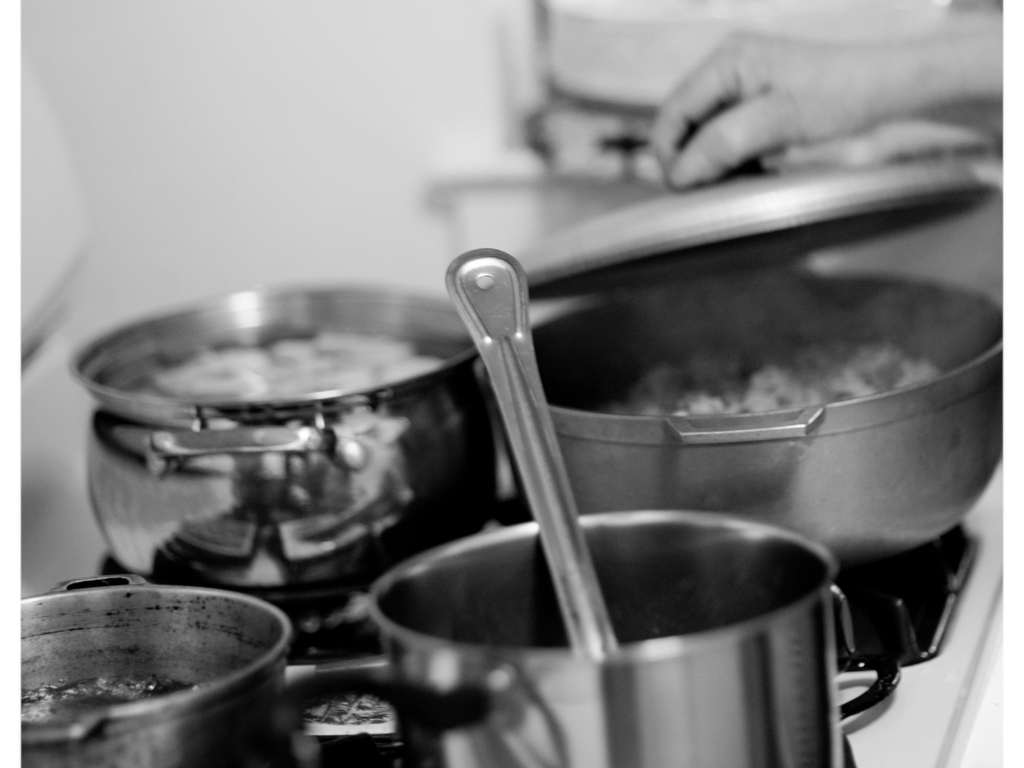Describe the composition and artistic elements present in this photograph. In the monochromatic palette, the photograph emphasizes texture and contrast over color, drawing attention to the metallic sheen of the pots and the diffuse steam. The framing suggests an intimate snapshot of everyday life, capturing the essence of home cooking with a candid and naturalistic style. 